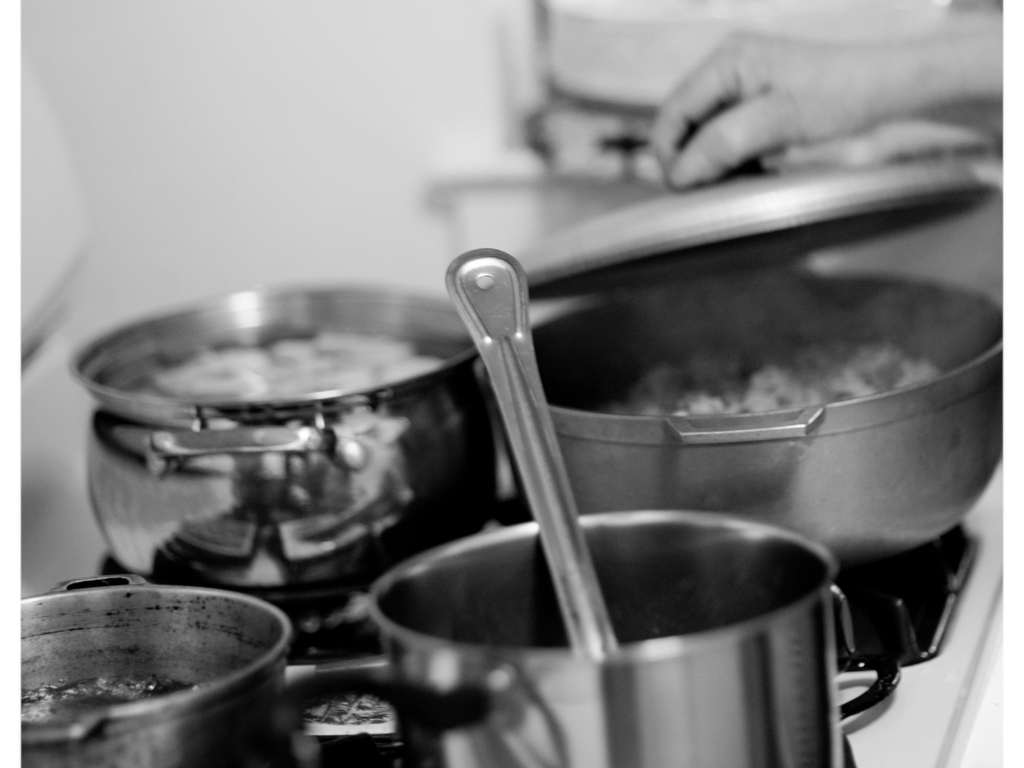Describe the composition and artistic elements present in this photograph. In the monochromatic palette, the photograph emphasizes texture and contrast over color, drawing attention to the metallic sheen of the pots and the diffuse steam. The framing suggests an intimate snapshot of everyday life, capturing the essence of home cooking with a candid and naturalistic style. 